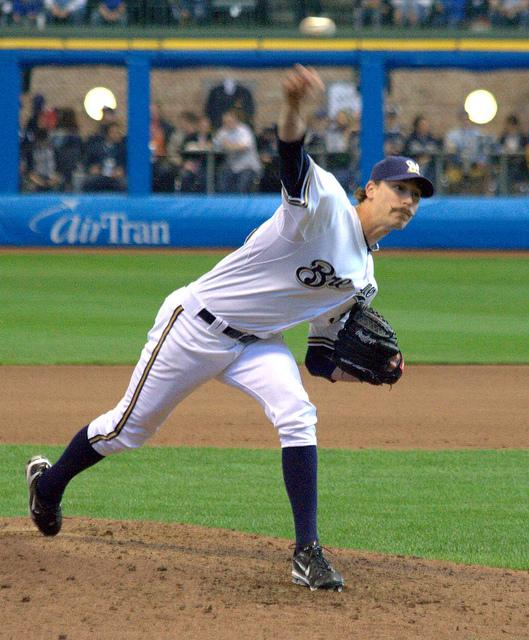To whom is this ball thrown?

Choices:
A) infield
B) ref
C) coach
D) batter batter 